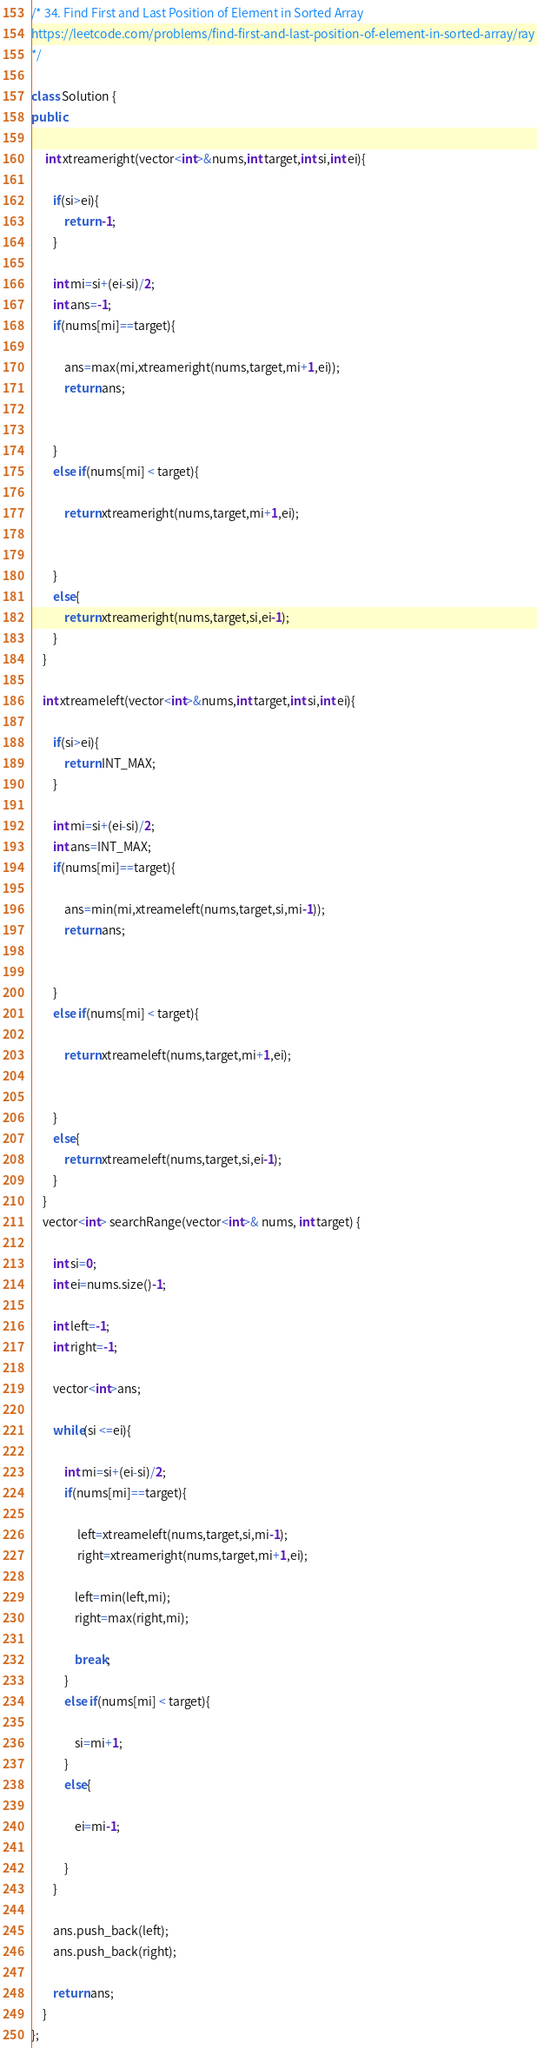Convert code to text. <code><loc_0><loc_0><loc_500><loc_500><_C++_>/* 34. Find First and Last Position of Element in Sorted Array
https://leetcode.com/problems/find-first-and-last-position-of-element-in-sorted-array/ray
*/

class Solution {
public:
    
     int xtreameright(vector<int>&nums,int target,int si,int ei){
        
        if(si>ei){
            return -1;
        }
        
        int mi=si+(ei-si)/2;
        int ans=-1;
        if(nums[mi]==target){
            
            ans=max(mi,xtreameright(nums,target,mi+1,ei));
            return ans;
            
            
        }
        else if(nums[mi] < target){
            
            return xtreameright(nums,target,mi+1,ei);
            
            
        }
        else{
            return xtreameright(nums,target,si,ei-1);
        }
    }
    
    int xtreameleft(vector<int>&nums,int target,int si,int ei){
        
        if(si>ei){
            return INT_MAX;
        }
        
        int mi=si+(ei-si)/2;
        int ans=INT_MAX;
        if(nums[mi]==target){
            
            ans=min(mi,xtreameleft(nums,target,si,mi-1));
            return ans;
            
            
        }
        else if(nums[mi] < target){
            
            return xtreameleft(nums,target,mi+1,ei);
            
            
        }
        else{
            return xtreameleft(nums,target,si,ei-1);
        }
    }
    vector<int> searchRange(vector<int>& nums, int target) {
       
        int si=0;
        int ei=nums.size()-1;
        
        int left=-1;
        int right=-1;
        
        vector<int>ans;
        
        while(si <=ei){
            
            int mi=si+(ei-si)/2;
            if(nums[mi]==target){
                
                 left=xtreameleft(nums,target,si,mi-1);
                 right=xtreameright(nums,target,mi+1,ei);
                
                left=min(left,mi);
                right=max(right,mi);
                
                break;
            }
            else if(nums[mi] < target){
                
                si=mi+1;
            }
            else{
                
                ei=mi-1;
                
            }
        }
        
        ans.push_back(left);
        ans.push_back(right);
        
        return ans;
    }
};</code> 